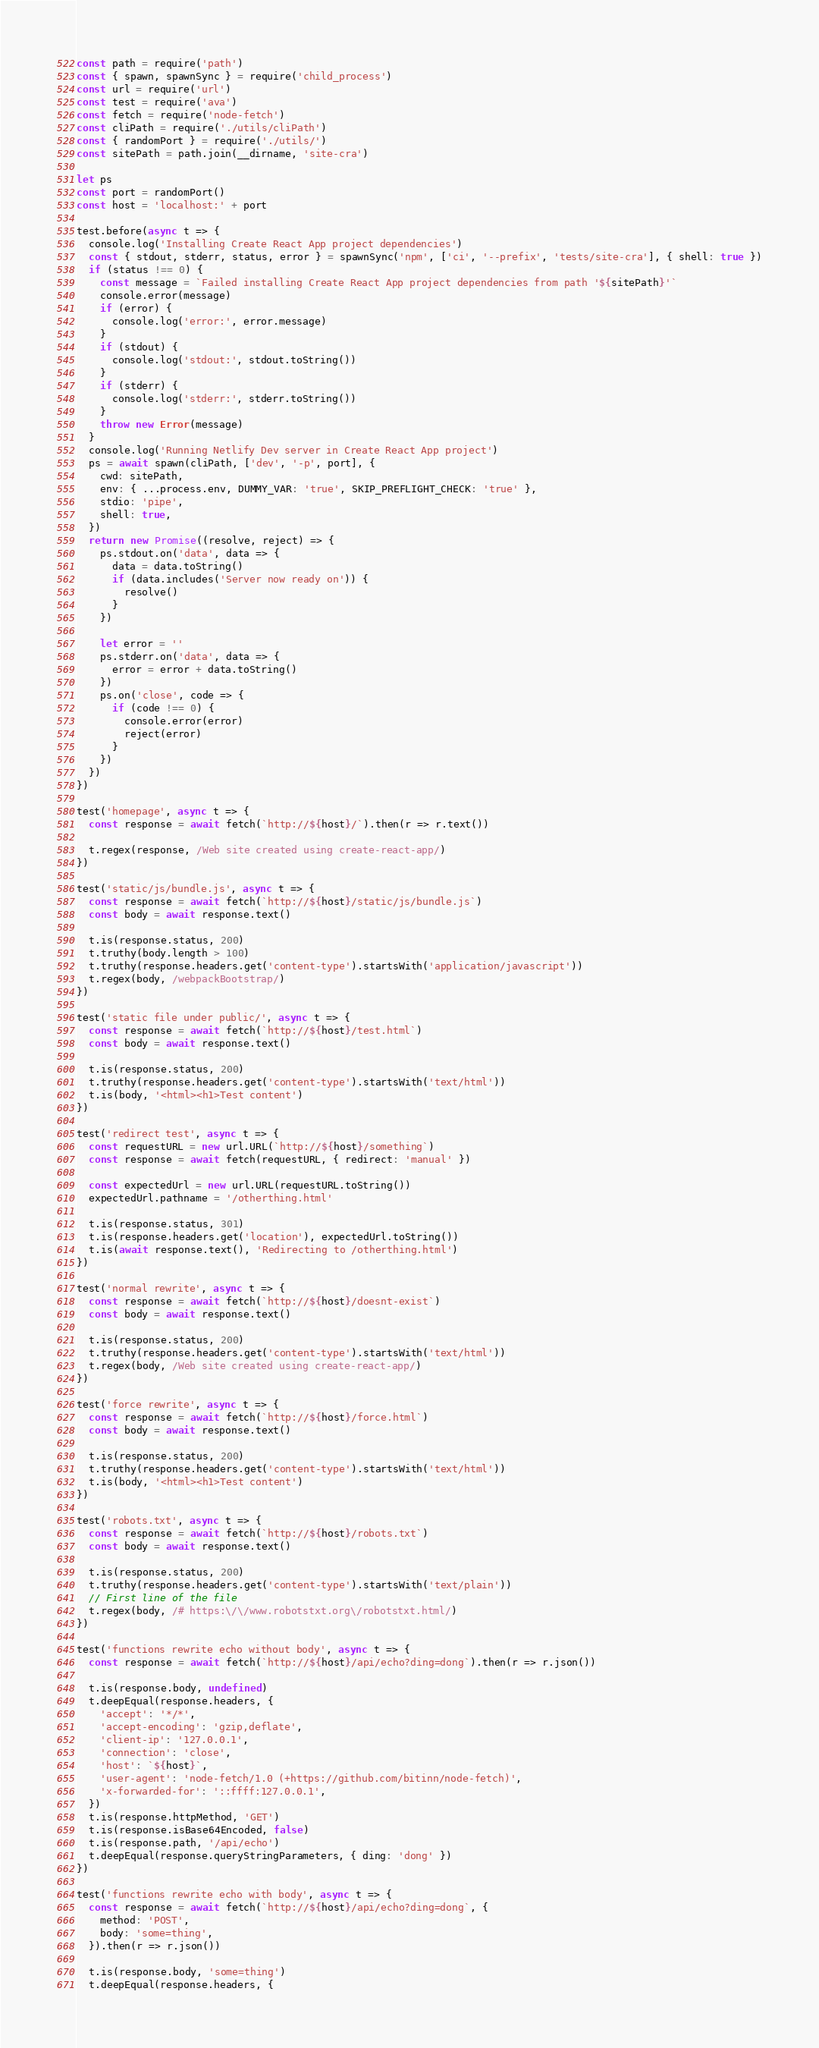<code> <loc_0><loc_0><loc_500><loc_500><_JavaScript_>const path = require('path')
const { spawn, spawnSync } = require('child_process')
const url = require('url')
const test = require('ava')
const fetch = require('node-fetch')
const cliPath = require('./utils/cliPath')
const { randomPort } = require('./utils/')
const sitePath = path.join(__dirname, 'site-cra')

let ps
const port = randomPort()
const host = 'localhost:' + port

test.before(async t => {
  console.log('Installing Create React App project dependencies')
  const { stdout, stderr, status, error } = spawnSync('npm', ['ci', '--prefix', 'tests/site-cra'], { shell: true })
  if (status !== 0) {
    const message = `Failed installing Create React App project dependencies from path '${sitePath}'`
    console.error(message)
    if (error) {
      console.log('error:', error.message)
    }
    if (stdout) {
      console.log('stdout:', stdout.toString())
    }
    if (stderr) {
      console.log('stderr:', stderr.toString())
    }
    throw new Error(message)
  }
  console.log('Running Netlify Dev server in Create React App project')
  ps = await spawn(cliPath, ['dev', '-p', port], {
    cwd: sitePath,
    env: { ...process.env, DUMMY_VAR: 'true', SKIP_PREFLIGHT_CHECK: 'true' },
    stdio: 'pipe',
    shell: true,
  })
  return new Promise((resolve, reject) => {
    ps.stdout.on('data', data => {
      data = data.toString()
      if (data.includes('Server now ready on')) {
        resolve()
      }
    })

    let error = ''
    ps.stderr.on('data', data => {
      error = error + data.toString()
    })
    ps.on('close', code => {
      if (code !== 0) {
        console.error(error)
        reject(error)
      }
    })
  })
})

test('homepage', async t => {
  const response = await fetch(`http://${host}/`).then(r => r.text())

  t.regex(response, /Web site created using create-react-app/)
})

test('static/js/bundle.js', async t => {
  const response = await fetch(`http://${host}/static/js/bundle.js`)
  const body = await response.text()

  t.is(response.status, 200)
  t.truthy(body.length > 100)
  t.truthy(response.headers.get('content-type').startsWith('application/javascript'))
  t.regex(body, /webpackBootstrap/)
})

test('static file under public/', async t => {
  const response = await fetch(`http://${host}/test.html`)
  const body = await response.text()

  t.is(response.status, 200)
  t.truthy(response.headers.get('content-type').startsWith('text/html'))
  t.is(body, '<html><h1>Test content')
})

test('redirect test', async t => {
  const requestURL = new url.URL(`http://${host}/something`)
  const response = await fetch(requestURL, { redirect: 'manual' })

  const expectedUrl = new url.URL(requestURL.toString())
  expectedUrl.pathname = '/otherthing.html'

  t.is(response.status, 301)
  t.is(response.headers.get('location'), expectedUrl.toString())
  t.is(await response.text(), 'Redirecting to /otherthing.html')
})

test('normal rewrite', async t => {
  const response = await fetch(`http://${host}/doesnt-exist`)
  const body = await response.text()

  t.is(response.status, 200)
  t.truthy(response.headers.get('content-type').startsWith('text/html'))
  t.regex(body, /Web site created using create-react-app/)
})

test('force rewrite', async t => {
  const response = await fetch(`http://${host}/force.html`)
  const body = await response.text()

  t.is(response.status, 200)
  t.truthy(response.headers.get('content-type').startsWith('text/html'))
  t.is(body, '<html><h1>Test content')
})

test('robots.txt', async t => {
  const response = await fetch(`http://${host}/robots.txt`)
  const body = await response.text()

  t.is(response.status, 200)
  t.truthy(response.headers.get('content-type').startsWith('text/plain'))
  // First line of the file
  t.regex(body, /# https:\/\/www.robotstxt.org\/robotstxt.html/)
})

test('functions rewrite echo without body', async t => {
  const response = await fetch(`http://${host}/api/echo?ding=dong`).then(r => r.json())

  t.is(response.body, undefined)
  t.deepEqual(response.headers, {
    'accept': '*/*',
    'accept-encoding': 'gzip,deflate',
    'client-ip': '127.0.0.1',
    'connection': 'close',
    'host': `${host}`,
    'user-agent': 'node-fetch/1.0 (+https://github.com/bitinn/node-fetch)',
    'x-forwarded-for': '::ffff:127.0.0.1',
  })
  t.is(response.httpMethod, 'GET')
  t.is(response.isBase64Encoded, false)
  t.is(response.path, '/api/echo')
  t.deepEqual(response.queryStringParameters, { ding: 'dong' })
})

test('functions rewrite echo with body', async t => {
  const response = await fetch(`http://${host}/api/echo?ding=dong`, {
    method: 'POST',
    body: 'some=thing',
  }).then(r => r.json())

  t.is(response.body, 'some=thing')
  t.deepEqual(response.headers, {</code> 